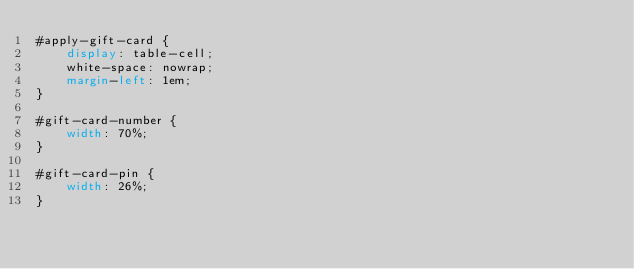<code> <loc_0><loc_0><loc_500><loc_500><_CSS_>#apply-gift-card {
    display: table-cell;
    white-space: nowrap;
    margin-left: 1em;
}

#gift-card-number {
    width: 70%;
}

#gift-card-pin {
    width: 26%;
}
</code> 